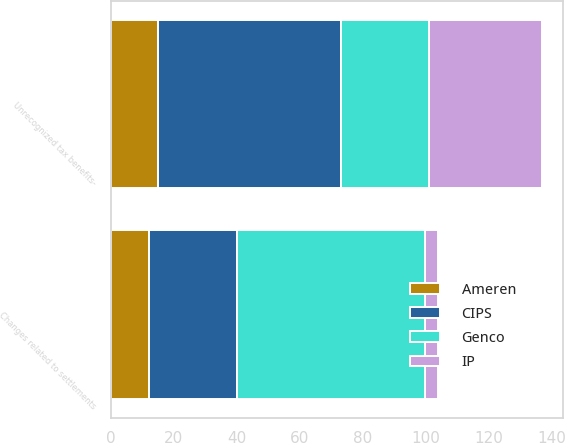Convert chart to OTSL. <chart><loc_0><loc_0><loc_500><loc_500><stacked_bar_chart><ecel><fcel>Unrecognized tax benefits-<fcel>Changes related to settlements<nl><fcel>Genco<fcel>28<fcel>60<nl><fcel>CIPS<fcel>58<fcel>28<nl><fcel>Ameren<fcel>15<fcel>12<nl><fcel>IP<fcel>36<fcel>4<nl></chart> 